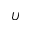<formula> <loc_0><loc_0><loc_500><loc_500>U</formula> 